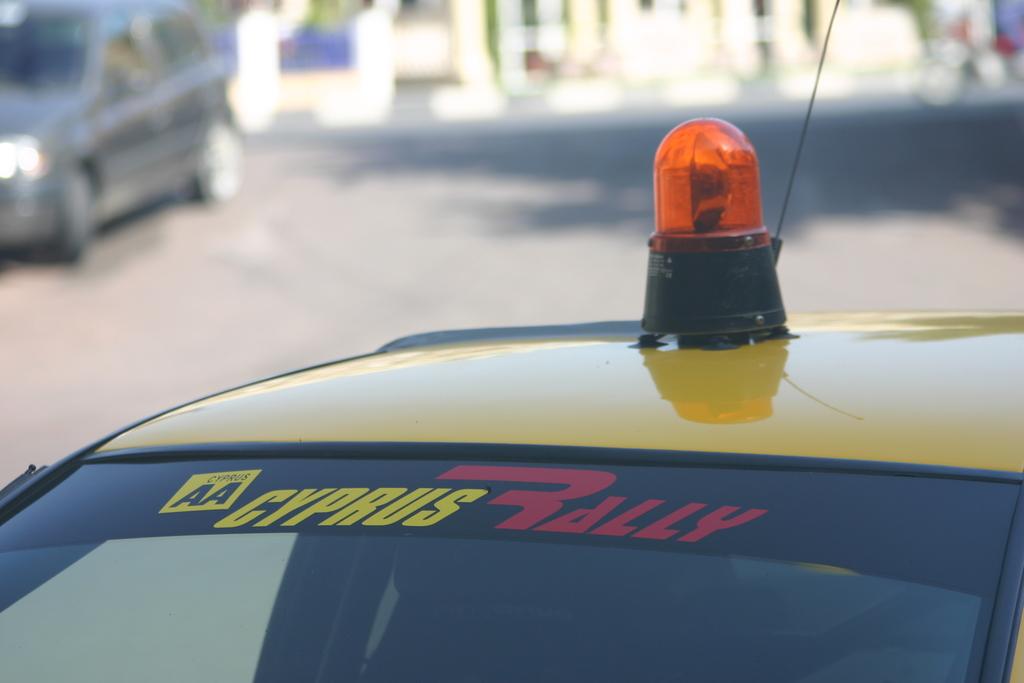What are the 2 letters on the left?
Make the answer very short. Aa. What does it say on the windshield?
Offer a very short reply. Cyprus rally. 